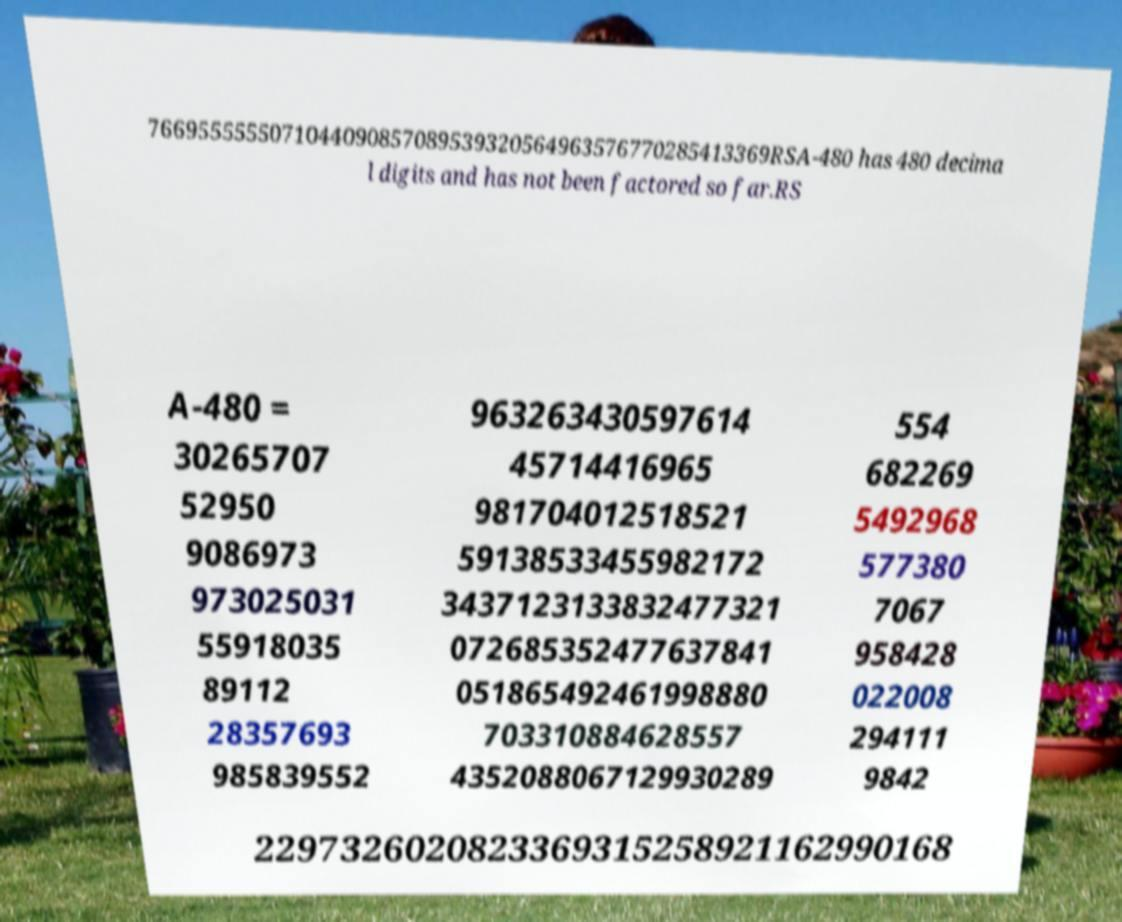Please read and relay the text visible in this image. What does it say? 7669555555071044090857089539320564963576770285413369RSA-480 has 480 decima l digits and has not been factored so far.RS A-480 = 30265707 52950 9086973 973025031 55918035 89112 28357693 985839552 963263430597614 45714416965 981704012518521 59138533455982172 3437123133832477321 072685352477637841 051865492461998880 703310884628557 4352088067129930289 554 682269 5492968 577380 7067 958428 022008 294111 9842 2297326020823369315258921162990168 